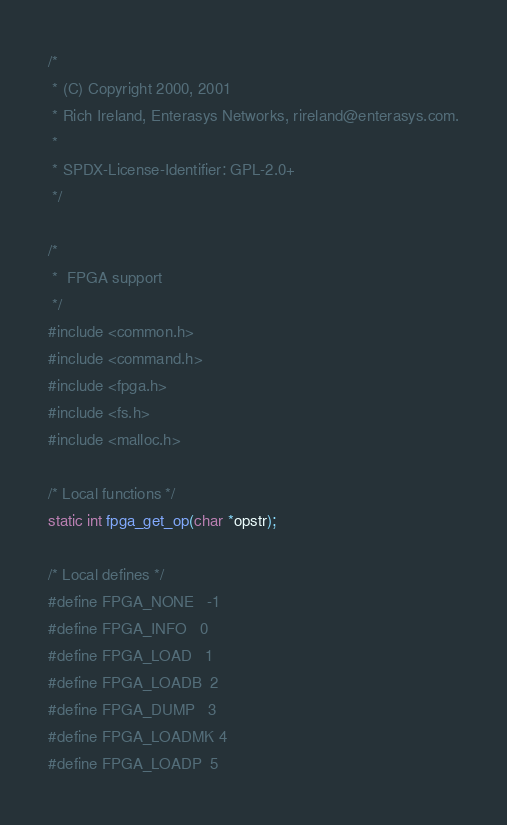<code> <loc_0><loc_0><loc_500><loc_500><_C_>/*
 * (C) Copyright 2000, 2001
 * Rich Ireland, Enterasys Networks, rireland@enterasys.com.
 *
 * SPDX-License-Identifier:	GPL-2.0+
 */

/*
 *  FPGA support
 */
#include <common.h>
#include <command.h>
#include <fpga.h>
#include <fs.h>
#include <malloc.h>

/* Local functions */
static int fpga_get_op(char *opstr);

/* Local defines */
#define FPGA_NONE   -1
#define FPGA_INFO   0
#define FPGA_LOAD   1
#define FPGA_LOADB  2
#define FPGA_DUMP   3
#define FPGA_LOADMK 4
#define FPGA_LOADP  5</code> 